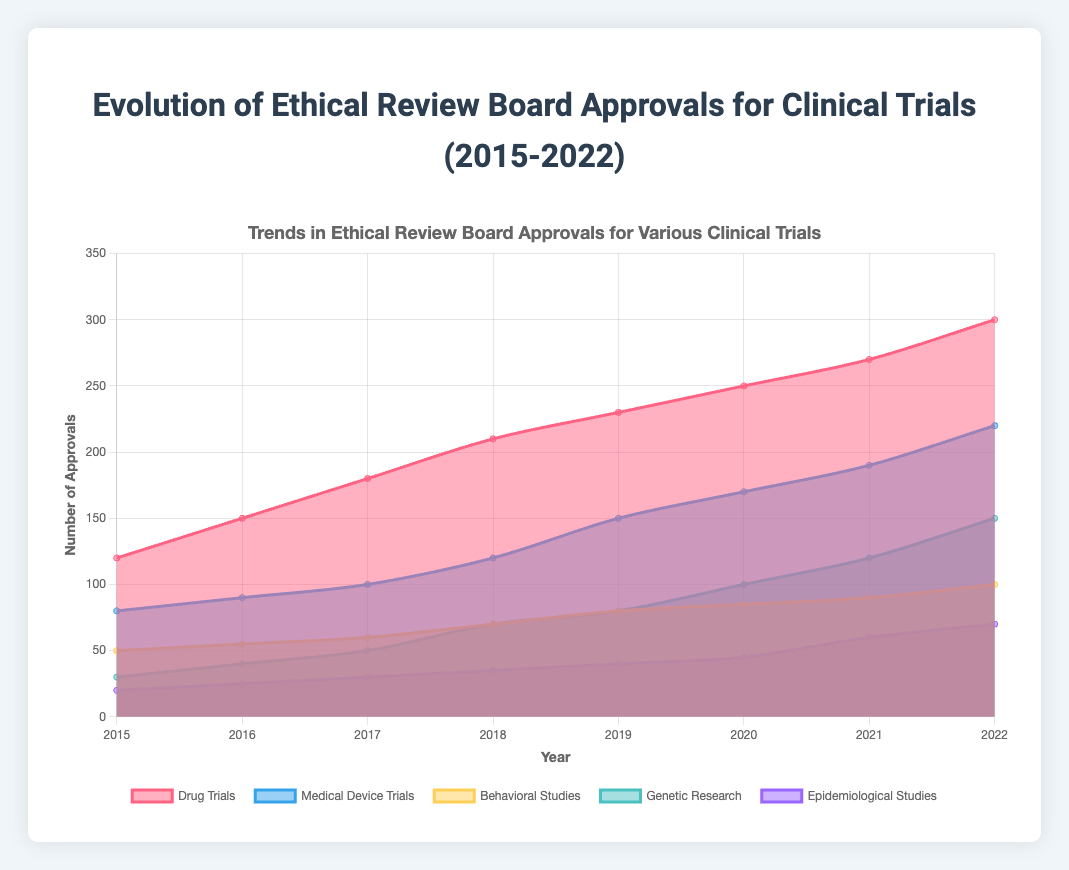What is the trend in the number of approvals for Drug Trials from 2015 to 2022? The number of approvals for Drug Trials steadily increased from 120 in 2015 to 300 in 2022. This trend can be observed by examining the increasing data points for Drug Trials over the given years.
Answer: Steadily increased Which type of clinical trial had the highest number of approvals in 2022? According to the data, Drug Trials had the highest number of approvals in 2022 with 300 approvals. This can be determined by comparing the data points for each type of clinical trial in 2022.
Answer: Drug Trials How does the number of approvals for Medical Device Trials in 2018 compare to Behavioral Studies in the same year? In 2018, Medical Device Trials had 120 approvals, whereas Behavioral Studies had 70 approvals. By comparing these values, it's evident that Medical Device Trials had more approvals than Behavioral Studies in 2018.
Answer: Medical Device Trials had more approvals What is the difference in the number of approvals between Genetic Research and Epidemiological Studies in 2020? In 2020, Genetic Research had 100 approvals and Epidemiological Studies had 45 approvals. The difference is calculated as 100 - 45 = 55.
Answer: 55 Which type of clinical trial saw the largest increase in approvals from 2015 to 2022? To determine this, we compare the increase in each type of trial by subtracting the 2015 values from the 2022 values. Drug Trials increased by 300 - 120 = 180, Medical Device Trials by 220 - 80 = 140, Behavioral Studies by 100 - 50 = 50, Genetic Research by 150 - 30 = 120, and Epidemiological Studies by 70 - 20 = 50. Drug Trials saw the largest increase.
Answer: Drug Trials What was the average number of approvals for Genetic Research from 2015 to 2022? The number of approvals for Genetic Research from 2015 to 2022 are 30, 40, 50, 70, 80, 100, 120, and 150. Adding these numbers gives 640, and dividing by 8 years, the average is 640 / 8 = 80.
Answer: 80 Which types of clinical trials showed a steady increase in approvals every year from 2015 to 2022? Drug Trials and Medical Device Trials showed a steady increase in approvals every year from 2015 to 2022. This can be seen by observing the continuous upward slope of their respective data points each year.
Answer: Drug Trials and Medical Device Trials In which year did Behavioral Studies see the highest number of approvals, and what was the value? Behavioral Studies saw the highest number of approvals in 2022 with 100 approvals. This is evident by comparing the values for Behavioral Studies across all years.
Answer: 2022, 100 How did the number of approvals for Epidemiological Studies change from 2015 to 2019? From 2015 to 2019, the number of approvals for Epidemiological Studies increased from 20 to 40. This shows a gradual increase in the number of approvals over these years.
Answer: Increased from 20 to 40 